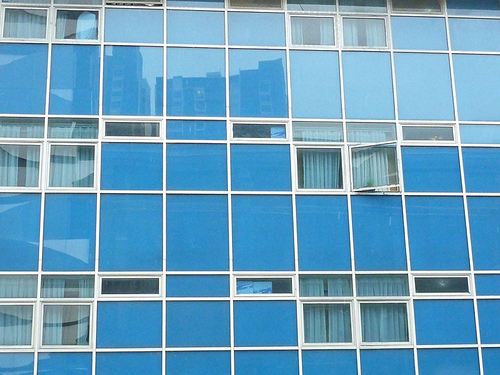<image>
Is there a top window in front of the in front? No. The top window is not in front of the in front. The spatial positioning shows a different relationship between these objects. 